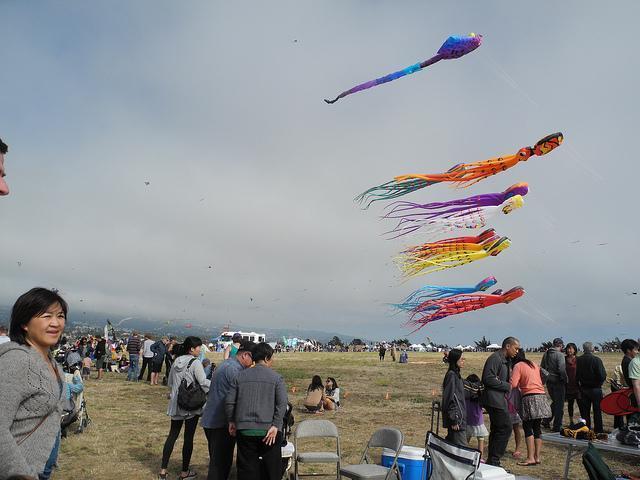How many chairs are visible?
Give a very brief answer. 2. How many kites are there?
Give a very brief answer. 4. How many people can you see?
Give a very brief answer. 7. How many orange lights can you see on the motorcycle?
Give a very brief answer. 0. 